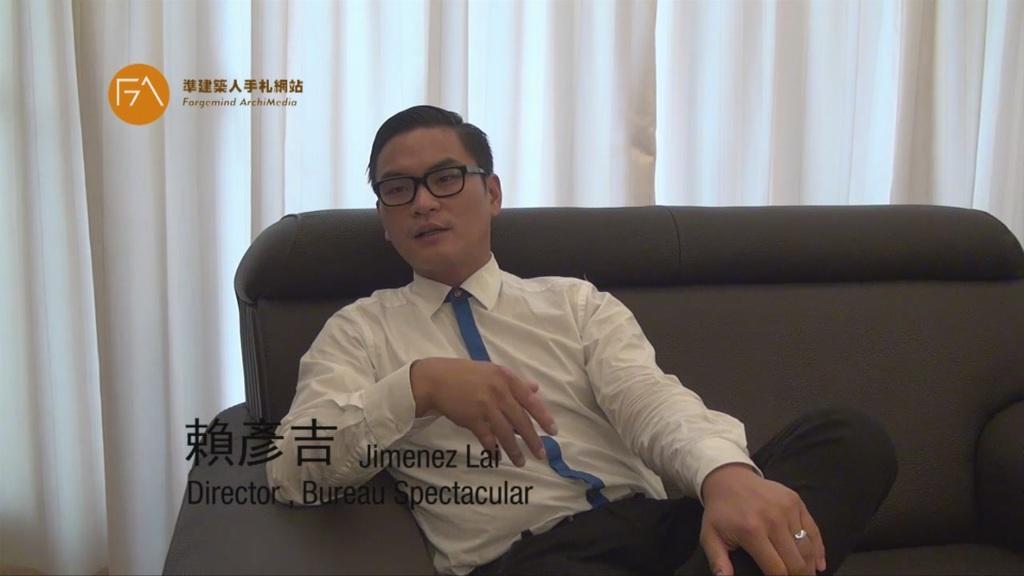Describe this image in one or two sentences. A man is sitting on the sofa, this is curtain. 